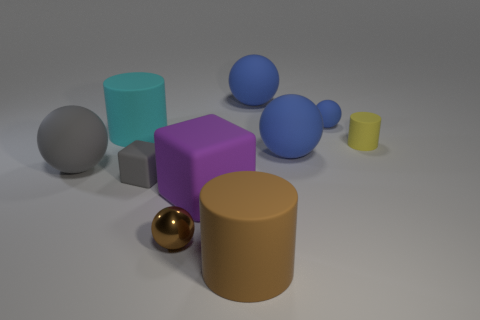Are there any other things that are made of the same material as the tiny brown ball?
Provide a succinct answer. No. Do the small ball right of the brown metallic thing and the gray thing that is in front of the big gray rubber ball have the same material?
Your answer should be compact. Yes. The tiny matte cube has what color?
Make the answer very short. Gray. What is the size of the gray matte thing that is right of the large cylinder on the left side of the brown thing in front of the small shiny sphere?
Ensure brevity in your answer.  Small. What number of other things are there of the same size as the brown matte cylinder?
Give a very brief answer. 5. How many blue things are made of the same material as the tiny blue ball?
Provide a succinct answer. 2. The rubber object behind the small blue object has what shape?
Keep it short and to the point. Sphere. Do the small gray thing and the blue thing that is in front of the yellow cylinder have the same material?
Offer a terse response. Yes. Are any purple things visible?
Keep it short and to the point. Yes. There is a rubber cylinder that is right of the cylinder that is in front of the tiny gray rubber cube; is there a tiny gray thing left of it?
Provide a succinct answer. Yes. 